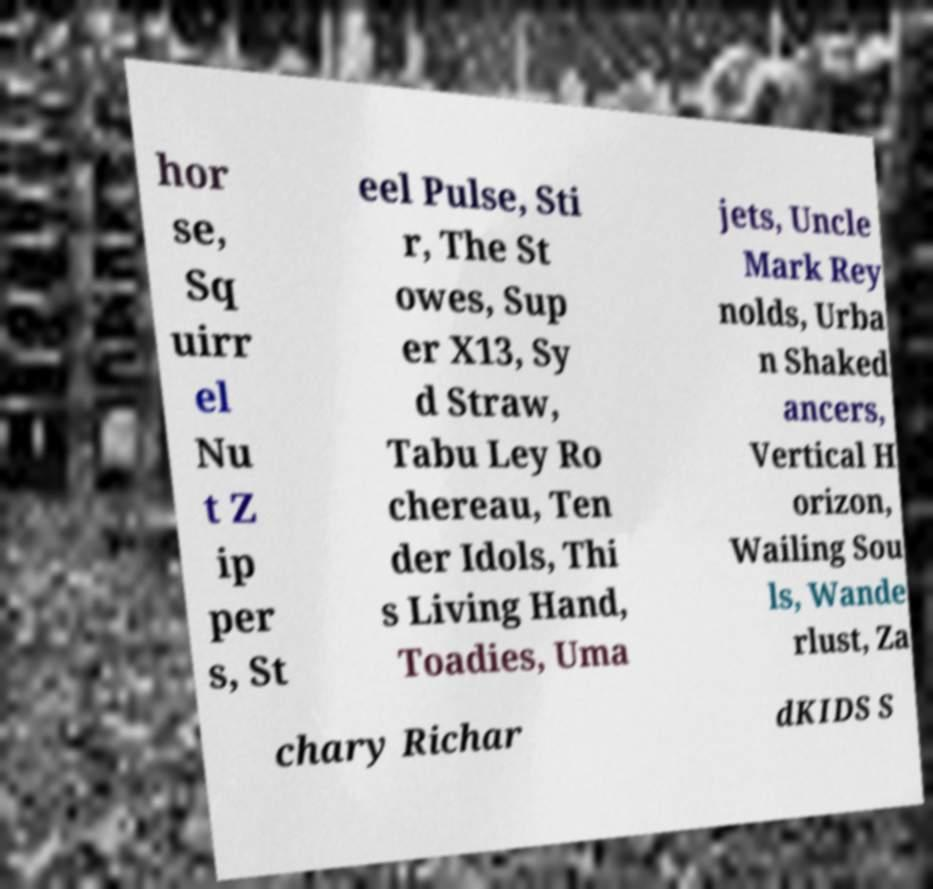Please identify and transcribe the text found in this image. hor se, Sq uirr el Nu t Z ip per s, St eel Pulse, Sti r, The St owes, Sup er X13, Sy d Straw, Tabu Ley Ro chereau, Ten der Idols, Thi s Living Hand, Toadies, Uma jets, Uncle Mark Rey nolds, Urba n Shaked ancers, Vertical H orizon, Wailing Sou ls, Wande rlust, Za chary Richar dKIDS S 